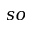<formula> <loc_0><loc_0><loc_500><loc_500>s o</formula> 